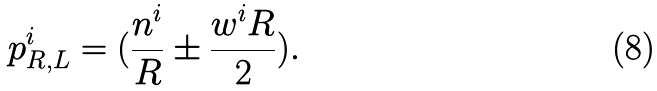Convert formula to latex. <formula><loc_0><loc_0><loc_500><loc_500>p ^ { i } _ { R , L } = ( \frac { n ^ { i } } { R } \pm \frac { w ^ { i } R } { 2 } ) .</formula> 